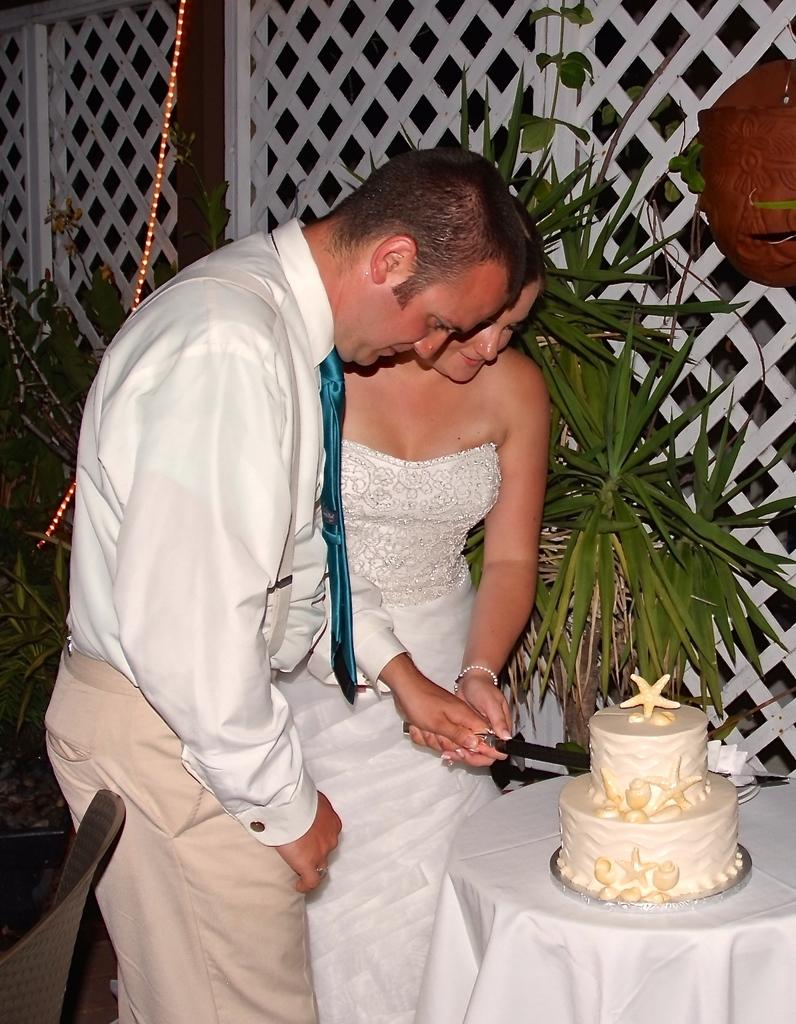How many people are in the image? There is a man and a woman in the image. What are the man and woman doing in the image? They are cutting a cake with a knife. What is covering the table in the image? There is a tablecloth in the image. What type of vegetation can be seen in the image? There are plants in the image. What type of furniture is present in the image? There are chairs in the image. What type of lighting is present in the image? There are lights in the image. What type of architectural feature is present in the image? There is a grille in the image. What object is present in the image? There is an object in the image. What type of balloon is floating above the man's head in the image? There is no balloon present in the image. How does the man's aunt feel about the cake in the image? There is no mention of an aunt in the image, so it cannot be determined how she feels about the cake. 